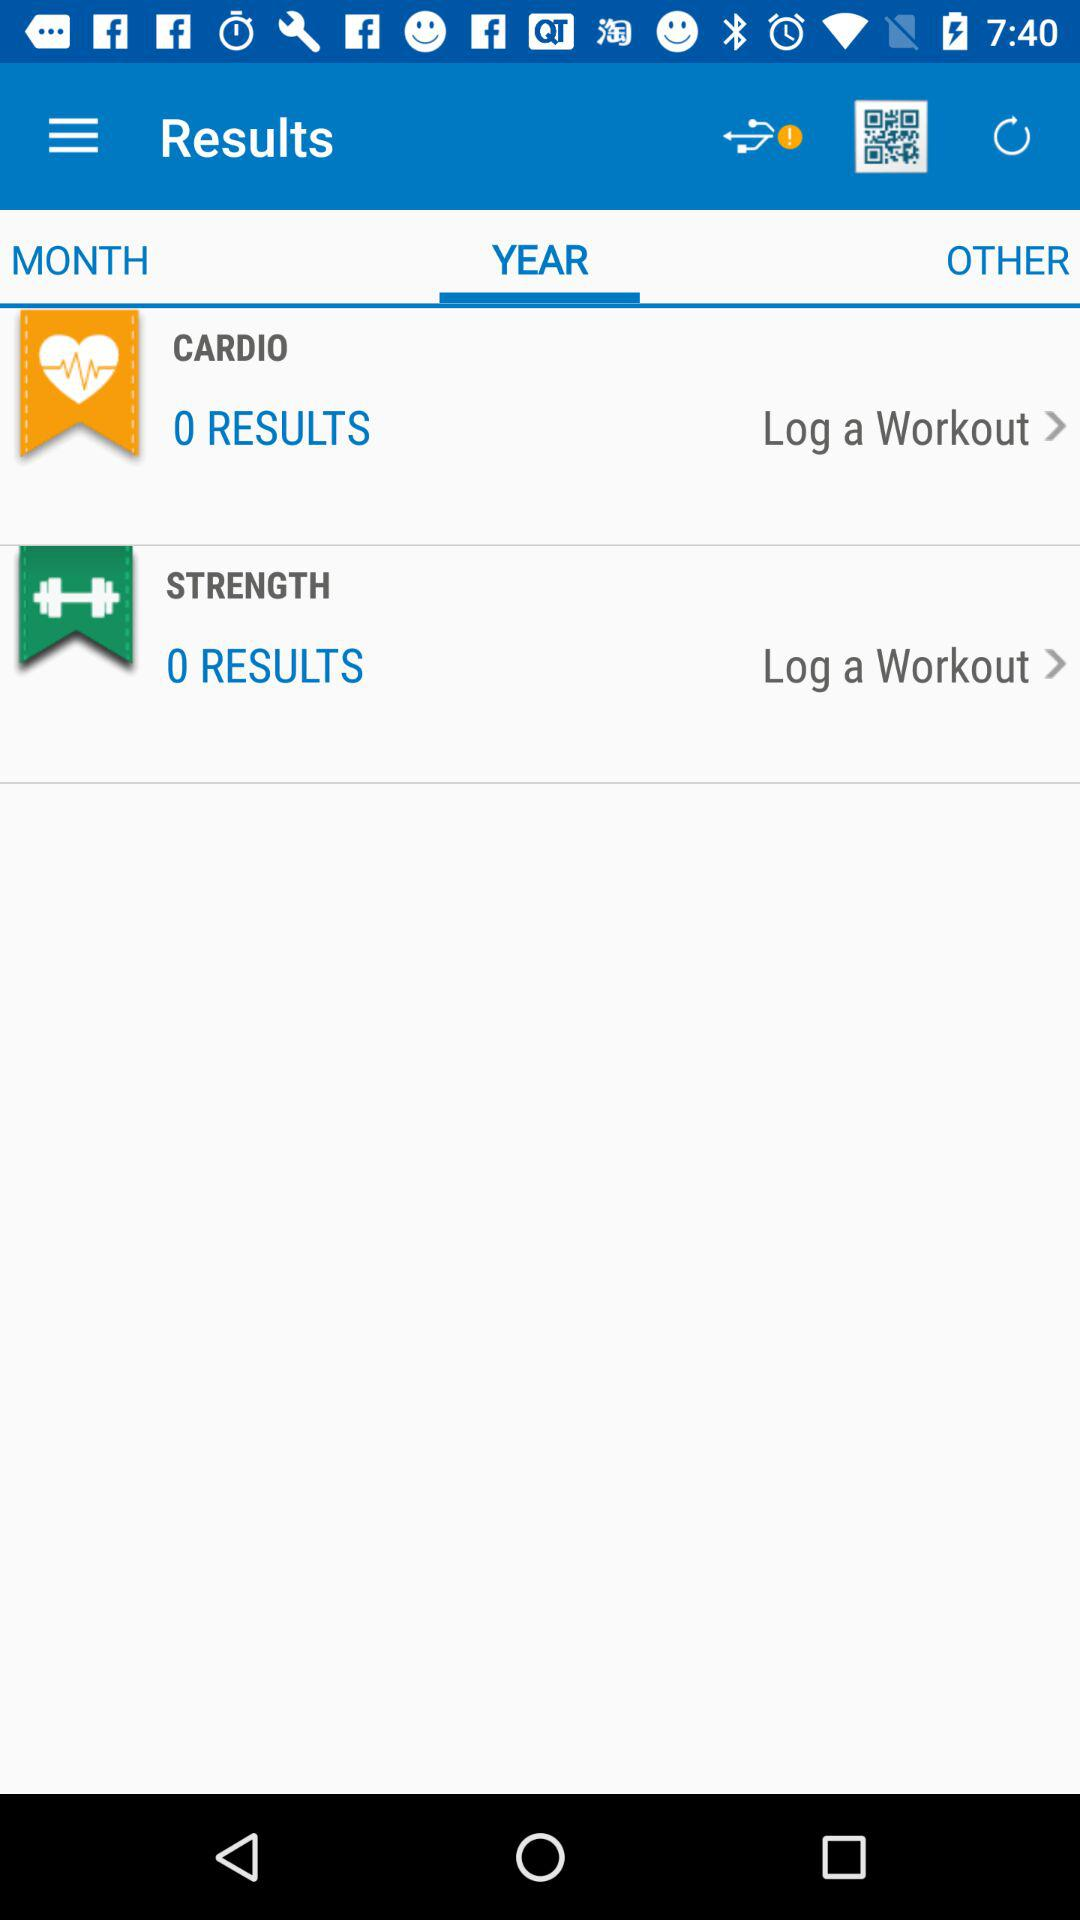Which tab is selected? The selected tab is "YEAR". 